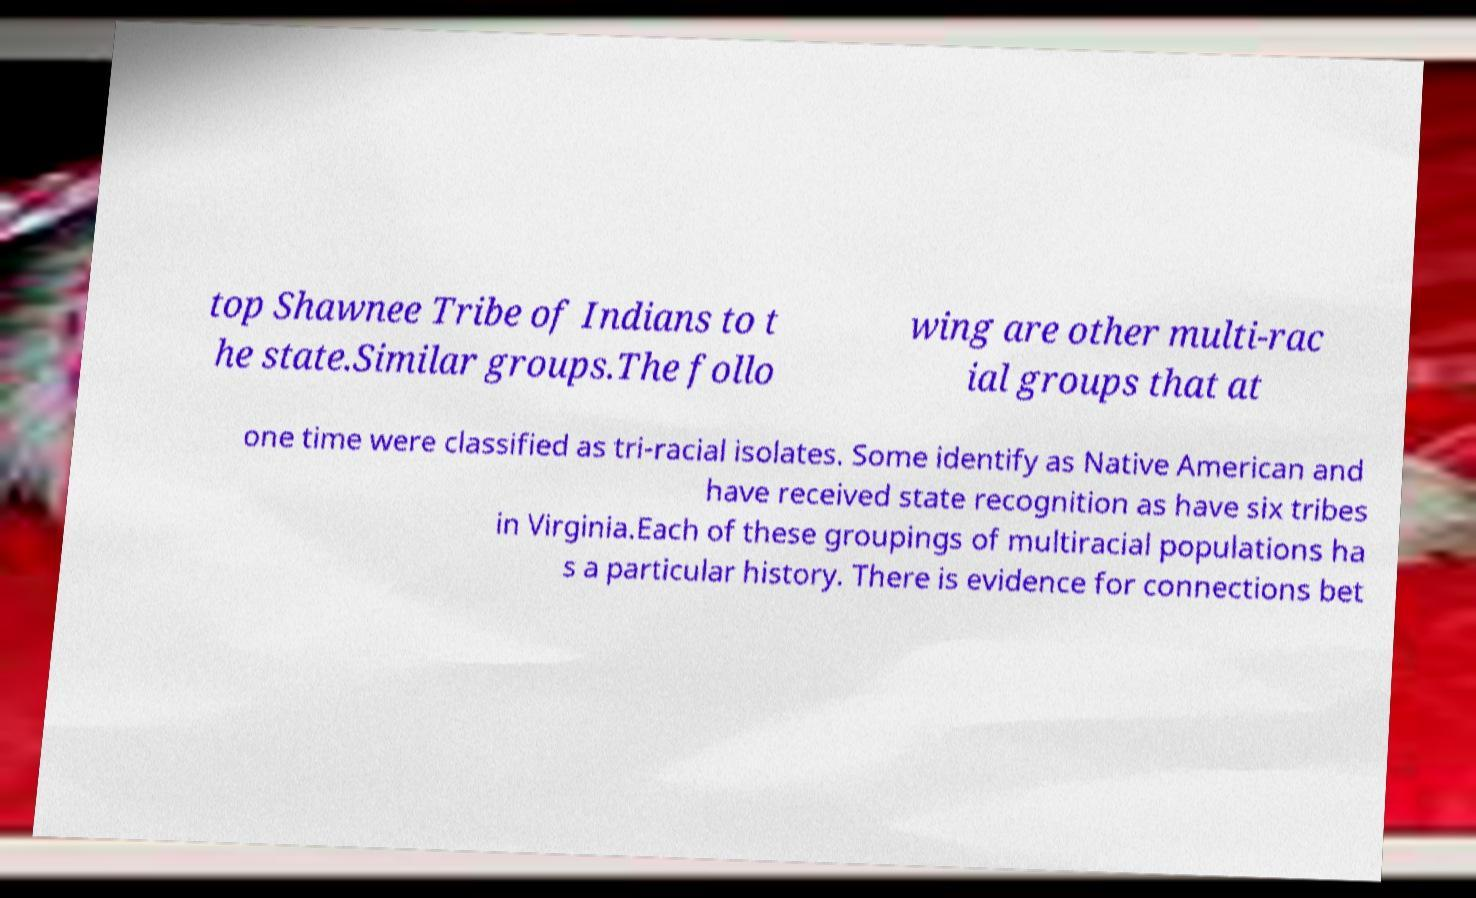Can you read and provide the text displayed in the image?This photo seems to have some interesting text. Can you extract and type it out for me? top Shawnee Tribe of Indians to t he state.Similar groups.The follo wing are other multi-rac ial groups that at one time were classified as tri-racial isolates. Some identify as Native American and have received state recognition as have six tribes in Virginia.Each of these groupings of multiracial populations ha s a particular history. There is evidence for connections bet 